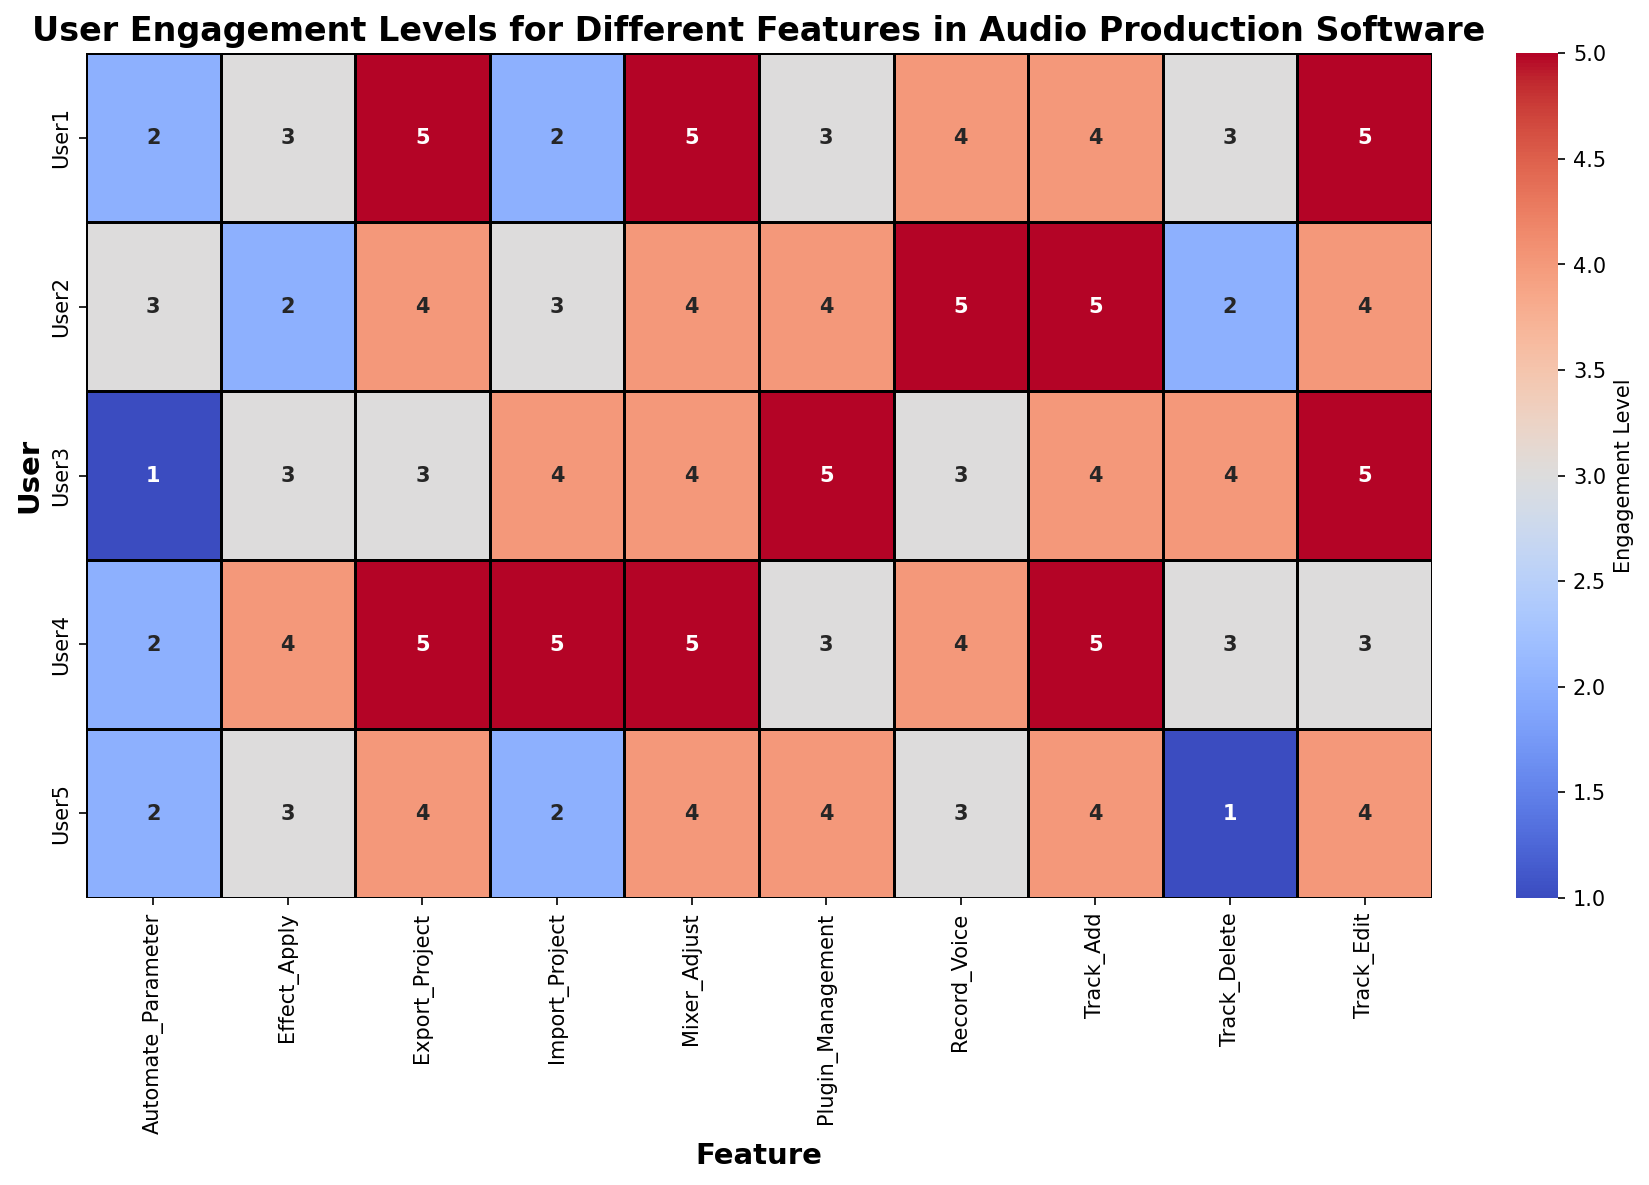What's the highest engagement level for 'Track_Edit'? Look at the column labeled 'Track_Edit' and identify the highest value, which is 5.
Answer: 5 Which user has the lowest engagement level for 'Track_Delete'? Look at the values in the 'Track_Delete' column and find the lowest value, which is 1, for User5.
Answer: User5 How does the engagement level of 'Effect_Apply' for User2 compare to that of User4? Check the 'Effect_Apply' row for both User2 and User4. User2 has an engagement level of 2, while User4 has a level of 4. User4's engagement level is higher.
Answer: User4's engagement level is higher What is the average engagement level for 'Plugin_Management' across all users? Add the engagement levels for 'Plugin_Management': 3 + 4 + 5 + 3 + 4 = 19. Then divide by the number of users, which is 5. (19/5 = 3.8).
Answer: 3.8 Which feature has the least variation in engagement levels among all users? Check the engagement levels for each feature and determine the one with the smallest range. 'Mixer_Adjust' has engagement levels of 4 and 5, indicating the least variation (range is 1).
Answer: Mixer_Adjust Compare the engagement levels of 'Export_Project' and 'Import_Project' for User4. User4's engagement level for 'Export_Project' is 5 and for 'Import_Project' is also 5.
Answer: They are equal What is the sum of engagement levels for 'Automate_Parameter' for all users? Add the engagement levels for 'Automate_Parameter': 2 + 3 + 1 + 2 + 2 = 10.
Answer: 10 Which feature has the highest average engagement level across all users? Calculate the average for each feature, and compare them. 'Track_Edit' has an average of (5+4+5+3+4)/5 = 4.2 which is the highest.
Answer: Track_Edit What’s the range of engagement levels for 'Record_Voice'? Identify the highest and lowest values for 'Record_Voice', which are 5 and 3 respectively. The range is 5 - 3 = 2.
Answer: 2 How frequently do users have an engagement level of 4 or more for 'Track_Add'? Count the number of times the engagement level is 4 or higher in 'Track_Add' column. There are 5 occurrences.
Answer: 5 